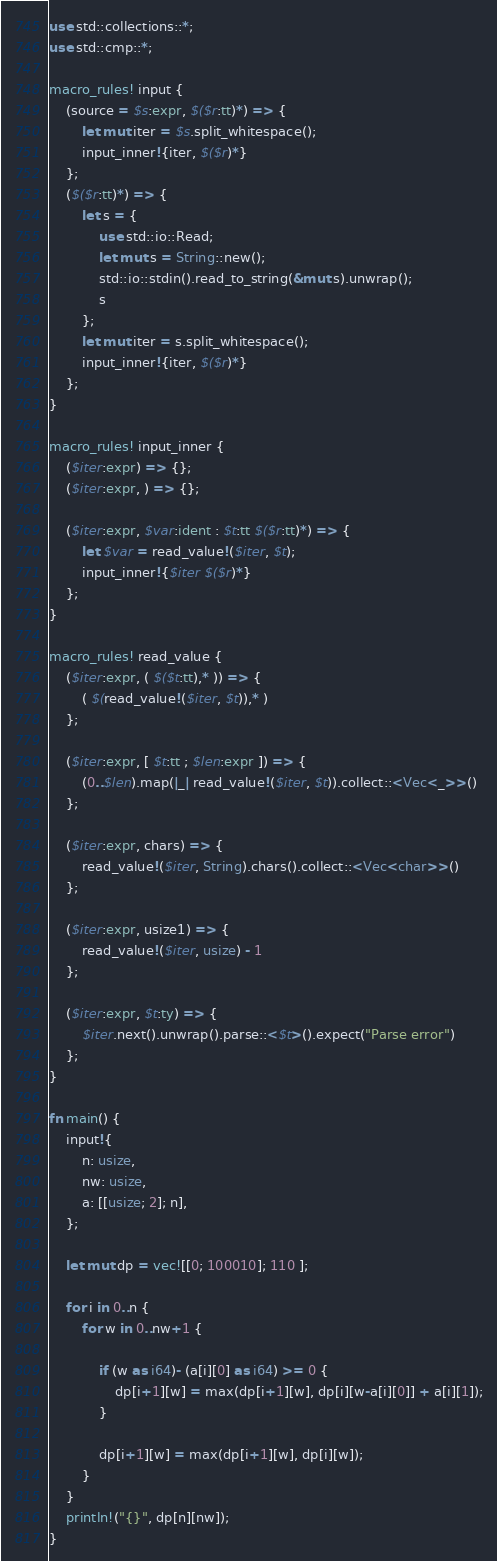<code> <loc_0><loc_0><loc_500><loc_500><_Rust_>use std::collections::*;
use std::cmp::*;

macro_rules! input {
    (source = $s:expr, $($r:tt)*) => {
        let mut iter = $s.split_whitespace();
        input_inner!{iter, $($r)*}
    };
    ($($r:tt)*) => {
        let s = {
            use std::io::Read;
            let mut s = String::new();
            std::io::stdin().read_to_string(&mut s).unwrap();
            s
        };
        let mut iter = s.split_whitespace();
        input_inner!{iter, $($r)*}
    };
}

macro_rules! input_inner {
    ($iter:expr) => {};
    ($iter:expr, ) => {};

    ($iter:expr, $var:ident : $t:tt $($r:tt)*) => {
        let $var = read_value!($iter, $t);
        input_inner!{$iter $($r)*}
    };
}

macro_rules! read_value {
    ($iter:expr, ( $($t:tt),* )) => {
        ( $(read_value!($iter, $t)),* )
    };

    ($iter:expr, [ $t:tt ; $len:expr ]) => {
        (0..$len).map(|_| read_value!($iter, $t)).collect::<Vec<_>>()
    };

    ($iter:expr, chars) => {
        read_value!($iter, String).chars().collect::<Vec<char>>()
    };

    ($iter:expr, usize1) => {
        read_value!($iter, usize) - 1
    };

    ($iter:expr, $t:ty) => {
        $iter.next().unwrap().parse::<$t>().expect("Parse error")
    };
}

fn main() {
    input!{
        n: usize,
        nw: usize,
        a: [[usize; 2]; n],
    };

    let mut dp = vec![[0; 100010]; 110 ];

    for i in 0..n {
        for w in 0..nw+1 {

            if (w as i64)- (a[i][0] as i64) >= 0 {
                dp[i+1][w] = max(dp[i+1][w], dp[i][w-a[i][0]] + a[i][1]);
            }

            dp[i+1][w] = max(dp[i+1][w], dp[i][w]);
        }
    }
    println!("{}", dp[n][nw]);
}
</code> 